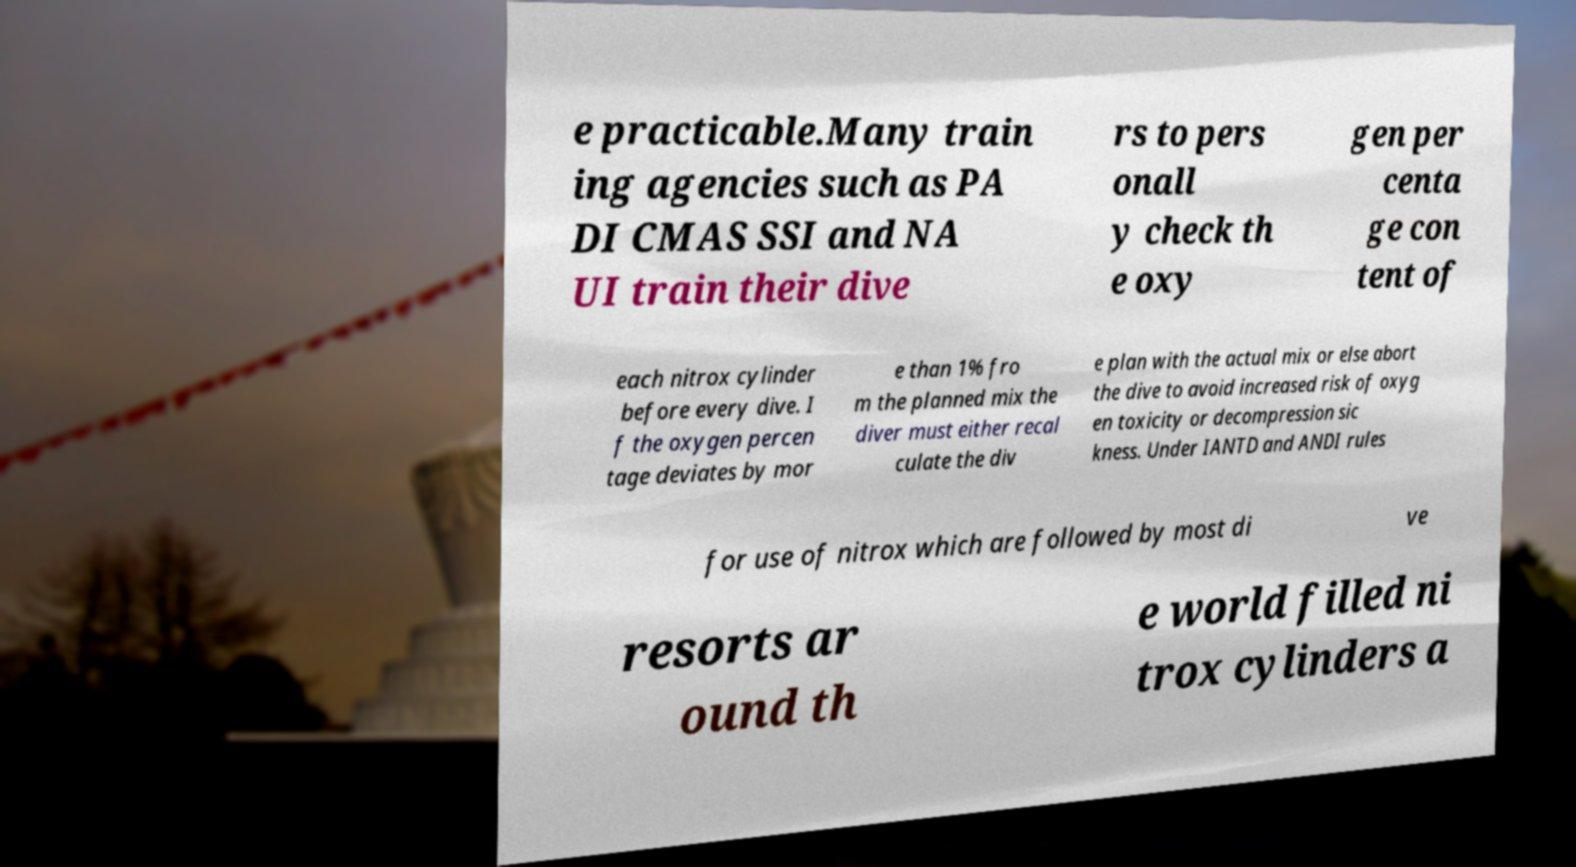Could you extract and type out the text from this image? e practicable.Many train ing agencies such as PA DI CMAS SSI and NA UI train their dive rs to pers onall y check th e oxy gen per centa ge con tent of each nitrox cylinder before every dive. I f the oxygen percen tage deviates by mor e than 1% fro m the planned mix the diver must either recal culate the div e plan with the actual mix or else abort the dive to avoid increased risk of oxyg en toxicity or decompression sic kness. Under IANTD and ANDI rules for use of nitrox which are followed by most di ve resorts ar ound th e world filled ni trox cylinders a 